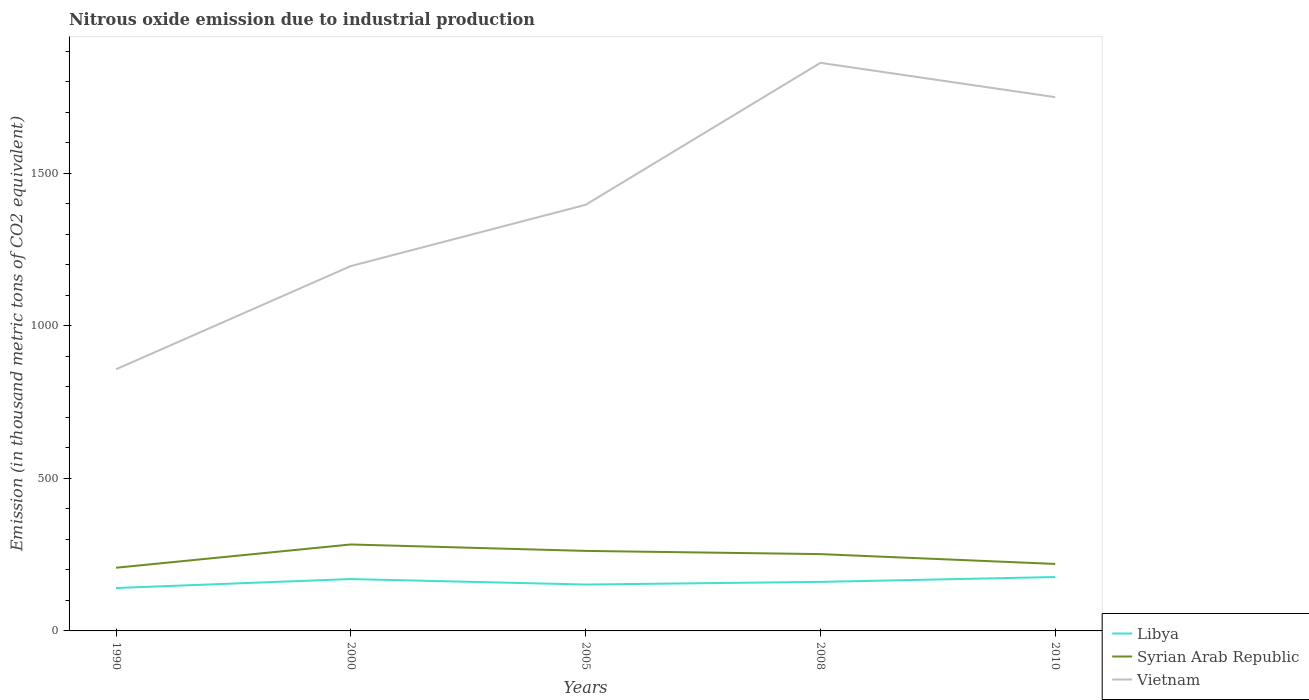How many different coloured lines are there?
Ensure brevity in your answer.  3. Is the number of lines equal to the number of legend labels?
Keep it short and to the point. Yes. Across all years, what is the maximum amount of nitrous oxide emitted in Syrian Arab Republic?
Provide a succinct answer. 207.1. What is the total amount of nitrous oxide emitted in Syrian Arab Republic in the graph?
Provide a short and direct response. 63.8. What is the difference between the highest and the second highest amount of nitrous oxide emitted in Libya?
Your response must be concise. 36. What is the difference between two consecutive major ticks on the Y-axis?
Your answer should be compact. 500. Does the graph contain any zero values?
Offer a very short reply. No. Does the graph contain grids?
Give a very brief answer. No. What is the title of the graph?
Your answer should be very brief. Nitrous oxide emission due to industrial production. Does "Pakistan" appear as one of the legend labels in the graph?
Give a very brief answer. No. What is the label or title of the Y-axis?
Give a very brief answer. Emission (in thousand metric tons of CO2 equivalent). What is the Emission (in thousand metric tons of CO2 equivalent) of Libya in 1990?
Offer a terse response. 140.6. What is the Emission (in thousand metric tons of CO2 equivalent) in Syrian Arab Republic in 1990?
Provide a succinct answer. 207.1. What is the Emission (in thousand metric tons of CO2 equivalent) in Vietnam in 1990?
Give a very brief answer. 857.4. What is the Emission (in thousand metric tons of CO2 equivalent) in Libya in 2000?
Your answer should be compact. 170. What is the Emission (in thousand metric tons of CO2 equivalent) of Syrian Arab Republic in 2000?
Your response must be concise. 283.3. What is the Emission (in thousand metric tons of CO2 equivalent) in Vietnam in 2000?
Your response must be concise. 1195.6. What is the Emission (in thousand metric tons of CO2 equivalent) of Libya in 2005?
Offer a terse response. 152. What is the Emission (in thousand metric tons of CO2 equivalent) of Syrian Arab Republic in 2005?
Your answer should be very brief. 262.2. What is the Emission (in thousand metric tons of CO2 equivalent) in Vietnam in 2005?
Your answer should be very brief. 1396.4. What is the Emission (in thousand metric tons of CO2 equivalent) of Libya in 2008?
Offer a very short reply. 160.7. What is the Emission (in thousand metric tons of CO2 equivalent) of Syrian Arab Republic in 2008?
Provide a short and direct response. 251.7. What is the Emission (in thousand metric tons of CO2 equivalent) of Vietnam in 2008?
Provide a short and direct response. 1861.6. What is the Emission (in thousand metric tons of CO2 equivalent) of Libya in 2010?
Offer a terse response. 176.6. What is the Emission (in thousand metric tons of CO2 equivalent) of Syrian Arab Republic in 2010?
Offer a terse response. 219.5. What is the Emission (in thousand metric tons of CO2 equivalent) of Vietnam in 2010?
Offer a terse response. 1749.1. Across all years, what is the maximum Emission (in thousand metric tons of CO2 equivalent) in Libya?
Offer a very short reply. 176.6. Across all years, what is the maximum Emission (in thousand metric tons of CO2 equivalent) of Syrian Arab Republic?
Provide a short and direct response. 283.3. Across all years, what is the maximum Emission (in thousand metric tons of CO2 equivalent) of Vietnam?
Your response must be concise. 1861.6. Across all years, what is the minimum Emission (in thousand metric tons of CO2 equivalent) in Libya?
Offer a very short reply. 140.6. Across all years, what is the minimum Emission (in thousand metric tons of CO2 equivalent) in Syrian Arab Republic?
Give a very brief answer. 207.1. Across all years, what is the minimum Emission (in thousand metric tons of CO2 equivalent) of Vietnam?
Give a very brief answer. 857.4. What is the total Emission (in thousand metric tons of CO2 equivalent) of Libya in the graph?
Your response must be concise. 799.9. What is the total Emission (in thousand metric tons of CO2 equivalent) of Syrian Arab Republic in the graph?
Ensure brevity in your answer.  1223.8. What is the total Emission (in thousand metric tons of CO2 equivalent) of Vietnam in the graph?
Provide a short and direct response. 7060.1. What is the difference between the Emission (in thousand metric tons of CO2 equivalent) in Libya in 1990 and that in 2000?
Offer a very short reply. -29.4. What is the difference between the Emission (in thousand metric tons of CO2 equivalent) of Syrian Arab Republic in 1990 and that in 2000?
Your response must be concise. -76.2. What is the difference between the Emission (in thousand metric tons of CO2 equivalent) in Vietnam in 1990 and that in 2000?
Your answer should be very brief. -338.2. What is the difference between the Emission (in thousand metric tons of CO2 equivalent) of Libya in 1990 and that in 2005?
Offer a very short reply. -11.4. What is the difference between the Emission (in thousand metric tons of CO2 equivalent) in Syrian Arab Republic in 1990 and that in 2005?
Your response must be concise. -55.1. What is the difference between the Emission (in thousand metric tons of CO2 equivalent) of Vietnam in 1990 and that in 2005?
Your answer should be compact. -539. What is the difference between the Emission (in thousand metric tons of CO2 equivalent) of Libya in 1990 and that in 2008?
Offer a terse response. -20.1. What is the difference between the Emission (in thousand metric tons of CO2 equivalent) of Syrian Arab Republic in 1990 and that in 2008?
Your response must be concise. -44.6. What is the difference between the Emission (in thousand metric tons of CO2 equivalent) in Vietnam in 1990 and that in 2008?
Provide a succinct answer. -1004.2. What is the difference between the Emission (in thousand metric tons of CO2 equivalent) in Libya in 1990 and that in 2010?
Offer a very short reply. -36. What is the difference between the Emission (in thousand metric tons of CO2 equivalent) of Syrian Arab Republic in 1990 and that in 2010?
Give a very brief answer. -12.4. What is the difference between the Emission (in thousand metric tons of CO2 equivalent) of Vietnam in 1990 and that in 2010?
Your answer should be compact. -891.7. What is the difference between the Emission (in thousand metric tons of CO2 equivalent) of Syrian Arab Republic in 2000 and that in 2005?
Give a very brief answer. 21.1. What is the difference between the Emission (in thousand metric tons of CO2 equivalent) in Vietnam in 2000 and that in 2005?
Your answer should be very brief. -200.8. What is the difference between the Emission (in thousand metric tons of CO2 equivalent) of Syrian Arab Republic in 2000 and that in 2008?
Offer a terse response. 31.6. What is the difference between the Emission (in thousand metric tons of CO2 equivalent) in Vietnam in 2000 and that in 2008?
Ensure brevity in your answer.  -666. What is the difference between the Emission (in thousand metric tons of CO2 equivalent) in Libya in 2000 and that in 2010?
Ensure brevity in your answer.  -6.6. What is the difference between the Emission (in thousand metric tons of CO2 equivalent) in Syrian Arab Republic in 2000 and that in 2010?
Your answer should be compact. 63.8. What is the difference between the Emission (in thousand metric tons of CO2 equivalent) of Vietnam in 2000 and that in 2010?
Give a very brief answer. -553.5. What is the difference between the Emission (in thousand metric tons of CO2 equivalent) of Syrian Arab Republic in 2005 and that in 2008?
Offer a terse response. 10.5. What is the difference between the Emission (in thousand metric tons of CO2 equivalent) of Vietnam in 2005 and that in 2008?
Ensure brevity in your answer.  -465.2. What is the difference between the Emission (in thousand metric tons of CO2 equivalent) of Libya in 2005 and that in 2010?
Your answer should be compact. -24.6. What is the difference between the Emission (in thousand metric tons of CO2 equivalent) in Syrian Arab Republic in 2005 and that in 2010?
Offer a terse response. 42.7. What is the difference between the Emission (in thousand metric tons of CO2 equivalent) of Vietnam in 2005 and that in 2010?
Offer a terse response. -352.7. What is the difference between the Emission (in thousand metric tons of CO2 equivalent) of Libya in 2008 and that in 2010?
Your answer should be very brief. -15.9. What is the difference between the Emission (in thousand metric tons of CO2 equivalent) of Syrian Arab Republic in 2008 and that in 2010?
Offer a terse response. 32.2. What is the difference between the Emission (in thousand metric tons of CO2 equivalent) in Vietnam in 2008 and that in 2010?
Ensure brevity in your answer.  112.5. What is the difference between the Emission (in thousand metric tons of CO2 equivalent) of Libya in 1990 and the Emission (in thousand metric tons of CO2 equivalent) of Syrian Arab Republic in 2000?
Ensure brevity in your answer.  -142.7. What is the difference between the Emission (in thousand metric tons of CO2 equivalent) in Libya in 1990 and the Emission (in thousand metric tons of CO2 equivalent) in Vietnam in 2000?
Ensure brevity in your answer.  -1055. What is the difference between the Emission (in thousand metric tons of CO2 equivalent) in Syrian Arab Republic in 1990 and the Emission (in thousand metric tons of CO2 equivalent) in Vietnam in 2000?
Offer a terse response. -988.5. What is the difference between the Emission (in thousand metric tons of CO2 equivalent) of Libya in 1990 and the Emission (in thousand metric tons of CO2 equivalent) of Syrian Arab Republic in 2005?
Keep it short and to the point. -121.6. What is the difference between the Emission (in thousand metric tons of CO2 equivalent) of Libya in 1990 and the Emission (in thousand metric tons of CO2 equivalent) of Vietnam in 2005?
Provide a succinct answer. -1255.8. What is the difference between the Emission (in thousand metric tons of CO2 equivalent) of Syrian Arab Republic in 1990 and the Emission (in thousand metric tons of CO2 equivalent) of Vietnam in 2005?
Give a very brief answer. -1189.3. What is the difference between the Emission (in thousand metric tons of CO2 equivalent) in Libya in 1990 and the Emission (in thousand metric tons of CO2 equivalent) in Syrian Arab Republic in 2008?
Offer a very short reply. -111.1. What is the difference between the Emission (in thousand metric tons of CO2 equivalent) in Libya in 1990 and the Emission (in thousand metric tons of CO2 equivalent) in Vietnam in 2008?
Your response must be concise. -1721. What is the difference between the Emission (in thousand metric tons of CO2 equivalent) of Syrian Arab Republic in 1990 and the Emission (in thousand metric tons of CO2 equivalent) of Vietnam in 2008?
Provide a short and direct response. -1654.5. What is the difference between the Emission (in thousand metric tons of CO2 equivalent) of Libya in 1990 and the Emission (in thousand metric tons of CO2 equivalent) of Syrian Arab Republic in 2010?
Your response must be concise. -78.9. What is the difference between the Emission (in thousand metric tons of CO2 equivalent) of Libya in 1990 and the Emission (in thousand metric tons of CO2 equivalent) of Vietnam in 2010?
Give a very brief answer. -1608.5. What is the difference between the Emission (in thousand metric tons of CO2 equivalent) in Syrian Arab Republic in 1990 and the Emission (in thousand metric tons of CO2 equivalent) in Vietnam in 2010?
Ensure brevity in your answer.  -1542. What is the difference between the Emission (in thousand metric tons of CO2 equivalent) of Libya in 2000 and the Emission (in thousand metric tons of CO2 equivalent) of Syrian Arab Republic in 2005?
Keep it short and to the point. -92.2. What is the difference between the Emission (in thousand metric tons of CO2 equivalent) of Libya in 2000 and the Emission (in thousand metric tons of CO2 equivalent) of Vietnam in 2005?
Provide a short and direct response. -1226.4. What is the difference between the Emission (in thousand metric tons of CO2 equivalent) in Syrian Arab Republic in 2000 and the Emission (in thousand metric tons of CO2 equivalent) in Vietnam in 2005?
Provide a succinct answer. -1113.1. What is the difference between the Emission (in thousand metric tons of CO2 equivalent) in Libya in 2000 and the Emission (in thousand metric tons of CO2 equivalent) in Syrian Arab Republic in 2008?
Offer a very short reply. -81.7. What is the difference between the Emission (in thousand metric tons of CO2 equivalent) in Libya in 2000 and the Emission (in thousand metric tons of CO2 equivalent) in Vietnam in 2008?
Ensure brevity in your answer.  -1691.6. What is the difference between the Emission (in thousand metric tons of CO2 equivalent) of Syrian Arab Republic in 2000 and the Emission (in thousand metric tons of CO2 equivalent) of Vietnam in 2008?
Your response must be concise. -1578.3. What is the difference between the Emission (in thousand metric tons of CO2 equivalent) in Libya in 2000 and the Emission (in thousand metric tons of CO2 equivalent) in Syrian Arab Republic in 2010?
Offer a terse response. -49.5. What is the difference between the Emission (in thousand metric tons of CO2 equivalent) of Libya in 2000 and the Emission (in thousand metric tons of CO2 equivalent) of Vietnam in 2010?
Give a very brief answer. -1579.1. What is the difference between the Emission (in thousand metric tons of CO2 equivalent) of Syrian Arab Republic in 2000 and the Emission (in thousand metric tons of CO2 equivalent) of Vietnam in 2010?
Make the answer very short. -1465.8. What is the difference between the Emission (in thousand metric tons of CO2 equivalent) of Libya in 2005 and the Emission (in thousand metric tons of CO2 equivalent) of Syrian Arab Republic in 2008?
Offer a very short reply. -99.7. What is the difference between the Emission (in thousand metric tons of CO2 equivalent) in Libya in 2005 and the Emission (in thousand metric tons of CO2 equivalent) in Vietnam in 2008?
Make the answer very short. -1709.6. What is the difference between the Emission (in thousand metric tons of CO2 equivalent) of Syrian Arab Republic in 2005 and the Emission (in thousand metric tons of CO2 equivalent) of Vietnam in 2008?
Your answer should be compact. -1599.4. What is the difference between the Emission (in thousand metric tons of CO2 equivalent) of Libya in 2005 and the Emission (in thousand metric tons of CO2 equivalent) of Syrian Arab Republic in 2010?
Ensure brevity in your answer.  -67.5. What is the difference between the Emission (in thousand metric tons of CO2 equivalent) of Libya in 2005 and the Emission (in thousand metric tons of CO2 equivalent) of Vietnam in 2010?
Offer a terse response. -1597.1. What is the difference between the Emission (in thousand metric tons of CO2 equivalent) of Syrian Arab Republic in 2005 and the Emission (in thousand metric tons of CO2 equivalent) of Vietnam in 2010?
Make the answer very short. -1486.9. What is the difference between the Emission (in thousand metric tons of CO2 equivalent) in Libya in 2008 and the Emission (in thousand metric tons of CO2 equivalent) in Syrian Arab Republic in 2010?
Your response must be concise. -58.8. What is the difference between the Emission (in thousand metric tons of CO2 equivalent) of Libya in 2008 and the Emission (in thousand metric tons of CO2 equivalent) of Vietnam in 2010?
Your response must be concise. -1588.4. What is the difference between the Emission (in thousand metric tons of CO2 equivalent) in Syrian Arab Republic in 2008 and the Emission (in thousand metric tons of CO2 equivalent) in Vietnam in 2010?
Provide a short and direct response. -1497.4. What is the average Emission (in thousand metric tons of CO2 equivalent) of Libya per year?
Offer a terse response. 159.98. What is the average Emission (in thousand metric tons of CO2 equivalent) of Syrian Arab Republic per year?
Your answer should be very brief. 244.76. What is the average Emission (in thousand metric tons of CO2 equivalent) of Vietnam per year?
Offer a terse response. 1412.02. In the year 1990, what is the difference between the Emission (in thousand metric tons of CO2 equivalent) in Libya and Emission (in thousand metric tons of CO2 equivalent) in Syrian Arab Republic?
Make the answer very short. -66.5. In the year 1990, what is the difference between the Emission (in thousand metric tons of CO2 equivalent) in Libya and Emission (in thousand metric tons of CO2 equivalent) in Vietnam?
Provide a short and direct response. -716.8. In the year 1990, what is the difference between the Emission (in thousand metric tons of CO2 equivalent) in Syrian Arab Republic and Emission (in thousand metric tons of CO2 equivalent) in Vietnam?
Provide a succinct answer. -650.3. In the year 2000, what is the difference between the Emission (in thousand metric tons of CO2 equivalent) in Libya and Emission (in thousand metric tons of CO2 equivalent) in Syrian Arab Republic?
Ensure brevity in your answer.  -113.3. In the year 2000, what is the difference between the Emission (in thousand metric tons of CO2 equivalent) in Libya and Emission (in thousand metric tons of CO2 equivalent) in Vietnam?
Provide a succinct answer. -1025.6. In the year 2000, what is the difference between the Emission (in thousand metric tons of CO2 equivalent) in Syrian Arab Republic and Emission (in thousand metric tons of CO2 equivalent) in Vietnam?
Keep it short and to the point. -912.3. In the year 2005, what is the difference between the Emission (in thousand metric tons of CO2 equivalent) of Libya and Emission (in thousand metric tons of CO2 equivalent) of Syrian Arab Republic?
Your answer should be very brief. -110.2. In the year 2005, what is the difference between the Emission (in thousand metric tons of CO2 equivalent) of Libya and Emission (in thousand metric tons of CO2 equivalent) of Vietnam?
Offer a very short reply. -1244.4. In the year 2005, what is the difference between the Emission (in thousand metric tons of CO2 equivalent) in Syrian Arab Republic and Emission (in thousand metric tons of CO2 equivalent) in Vietnam?
Keep it short and to the point. -1134.2. In the year 2008, what is the difference between the Emission (in thousand metric tons of CO2 equivalent) of Libya and Emission (in thousand metric tons of CO2 equivalent) of Syrian Arab Republic?
Offer a terse response. -91. In the year 2008, what is the difference between the Emission (in thousand metric tons of CO2 equivalent) of Libya and Emission (in thousand metric tons of CO2 equivalent) of Vietnam?
Give a very brief answer. -1700.9. In the year 2008, what is the difference between the Emission (in thousand metric tons of CO2 equivalent) of Syrian Arab Republic and Emission (in thousand metric tons of CO2 equivalent) of Vietnam?
Keep it short and to the point. -1609.9. In the year 2010, what is the difference between the Emission (in thousand metric tons of CO2 equivalent) of Libya and Emission (in thousand metric tons of CO2 equivalent) of Syrian Arab Republic?
Ensure brevity in your answer.  -42.9. In the year 2010, what is the difference between the Emission (in thousand metric tons of CO2 equivalent) of Libya and Emission (in thousand metric tons of CO2 equivalent) of Vietnam?
Keep it short and to the point. -1572.5. In the year 2010, what is the difference between the Emission (in thousand metric tons of CO2 equivalent) in Syrian Arab Republic and Emission (in thousand metric tons of CO2 equivalent) in Vietnam?
Your response must be concise. -1529.6. What is the ratio of the Emission (in thousand metric tons of CO2 equivalent) of Libya in 1990 to that in 2000?
Your response must be concise. 0.83. What is the ratio of the Emission (in thousand metric tons of CO2 equivalent) of Syrian Arab Republic in 1990 to that in 2000?
Offer a very short reply. 0.73. What is the ratio of the Emission (in thousand metric tons of CO2 equivalent) in Vietnam in 1990 to that in 2000?
Make the answer very short. 0.72. What is the ratio of the Emission (in thousand metric tons of CO2 equivalent) in Libya in 1990 to that in 2005?
Your answer should be very brief. 0.93. What is the ratio of the Emission (in thousand metric tons of CO2 equivalent) in Syrian Arab Republic in 1990 to that in 2005?
Your answer should be very brief. 0.79. What is the ratio of the Emission (in thousand metric tons of CO2 equivalent) of Vietnam in 1990 to that in 2005?
Provide a succinct answer. 0.61. What is the ratio of the Emission (in thousand metric tons of CO2 equivalent) of Libya in 1990 to that in 2008?
Your answer should be compact. 0.87. What is the ratio of the Emission (in thousand metric tons of CO2 equivalent) of Syrian Arab Republic in 1990 to that in 2008?
Your answer should be compact. 0.82. What is the ratio of the Emission (in thousand metric tons of CO2 equivalent) of Vietnam in 1990 to that in 2008?
Make the answer very short. 0.46. What is the ratio of the Emission (in thousand metric tons of CO2 equivalent) of Libya in 1990 to that in 2010?
Keep it short and to the point. 0.8. What is the ratio of the Emission (in thousand metric tons of CO2 equivalent) of Syrian Arab Republic in 1990 to that in 2010?
Make the answer very short. 0.94. What is the ratio of the Emission (in thousand metric tons of CO2 equivalent) in Vietnam in 1990 to that in 2010?
Give a very brief answer. 0.49. What is the ratio of the Emission (in thousand metric tons of CO2 equivalent) of Libya in 2000 to that in 2005?
Your answer should be compact. 1.12. What is the ratio of the Emission (in thousand metric tons of CO2 equivalent) in Syrian Arab Republic in 2000 to that in 2005?
Ensure brevity in your answer.  1.08. What is the ratio of the Emission (in thousand metric tons of CO2 equivalent) of Vietnam in 2000 to that in 2005?
Keep it short and to the point. 0.86. What is the ratio of the Emission (in thousand metric tons of CO2 equivalent) of Libya in 2000 to that in 2008?
Provide a succinct answer. 1.06. What is the ratio of the Emission (in thousand metric tons of CO2 equivalent) in Syrian Arab Republic in 2000 to that in 2008?
Ensure brevity in your answer.  1.13. What is the ratio of the Emission (in thousand metric tons of CO2 equivalent) in Vietnam in 2000 to that in 2008?
Provide a succinct answer. 0.64. What is the ratio of the Emission (in thousand metric tons of CO2 equivalent) of Libya in 2000 to that in 2010?
Offer a very short reply. 0.96. What is the ratio of the Emission (in thousand metric tons of CO2 equivalent) of Syrian Arab Republic in 2000 to that in 2010?
Your response must be concise. 1.29. What is the ratio of the Emission (in thousand metric tons of CO2 equivalent) in Vietnam in 2000 to that in 2010?
Offer a terse response. 0.68. What is the ratio of the Emission (in thousand metric tons of CO2 equivalent) in Libya in 2005 to that in 2008?
Make the answer very short. 0.95. What is the ratio of the Emission (in thousand metric tons of CO2 equivalent) of Syrian Arab Republic in 2005 to that in 2008?
Your answer should be very brief. 1.04. What is the ratio of the Emission (in thousand metric tons of CO2 equivalent) in Vietnam in 2005 to that in 2008?
Your answer should be very brief. 0.75. What is the ratio of the Emission (in thousand metric tons of CO2 equivalent) of Libya in 2005 to that in 2010?
Ensure brevity in your answer.  0.86. What is the ratio of the Emission (in thousand metric tons of CO2 equivalent) in Syrian Arab Republic in 2005 to that in 2010?
Your answer should be very brief. 1.19. What is the ratio of the Emission (in thousand metric tons of CO2 equivalent) in Vietnam in 2005 to that in 2010?
Make the answer very short. 0.8. What is the ratio of the Emission (in thousand metric tons of CO2 equivalent) of Libya in 2008 to that in 2010?
Make the answer very short. 0.91. What is the ratio of the Emission (in thousand metric tons of CO2 equivalent) of Syrian Arab Republic in 2008 to that in 2010?
Keep it short and to the point. 1.15. What is the ratio of the Emission (in thousand metric tons of CO2 equivalent) in Vietnam in 2008 to that in 2010?
Your answer should be compact. 1.06. What is the difference between the highest and the second highest Emission (in thousand metric tons of CO2 equivalent) in Libya?
Provide a succinct answer. 6.6. What is the difference between the highest and the second highest Emission (in thousand metric tons of CO2 equivalent) in Syrian Arab Republic?
Make the answer very short. 21.1. What is the difference between the highest and the second highest Emission (in thousand metric tons of CO2 equivalent) of Vietnam?
Make the answer very short. 112.5. What is the difference between the highest and the lowest Emission (in thousand metric tons of CO2 equivalent) of Syrian Arab Republic?
Make the answer very short. 76.2. What is the difference between the highest and the lowest Emission (in thousand metric tons of CO2 equivalent) of Vietnam?
Offer a terse response. 1004.2. 